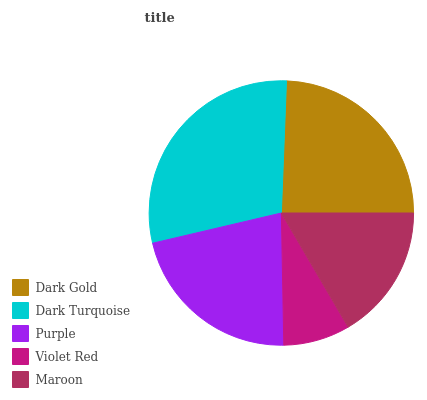Is Violet Red the minimum?
Answer yes or no. Yes. Is Dark Turquoise the maximum?
Answer yes or no. Yes. Is Purple the minimum?
Answer yes or no. No. Is Purple the maximum?
Answer yes or no. No. Is Dark Turquoise greater than Purple?
Answer yes or no. Yes. Is Purple less than Dark Turquoise?
Answer yes or no. Yes. Is Purple greater than Dark Turquoise?
Answer yes or no. No. Is Dark Turquoise less than Purple?
Answer yes or no. No. Is Purple the high median?
Answer yes or no. Yes. Is Purple the low median?
Answer yes or no. Yes. Is Violet Red the high median?
Answer yes or no. No. Is Dark Turquoise the low median?
Answer yes or no. No. 